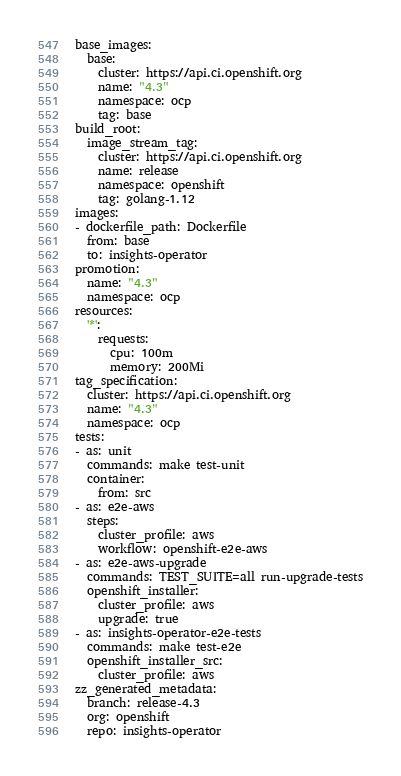Convert code to text. <code><loc_0><loc_0><loc_500><loc_500><_YAML_>base_images:
  base:
    cluster: https://api.ci.openshift.org
    name: "4.3"
    namespace: ocp
    tag: base
build_root:
  image_stream_tag:
    cluster: https://api.ci.openshift.org
    name: release
    namespace: openshift
    tag: golang-1.12
images:
- dockerfile_path: Dockerfile
  from: base
  to: insights-operator
promotion:
  name: "4.3"
  namespace: ocp
resources:
  '*':
    requests:
      cpu: 100m
      memory: 200Mi
tag_specification:
  cluster: https://api.ci.openshift.org
  name: "4.3"
  namespace: ocp
tests:
- as: unit
  commands: make test-unit
  container:
    from: src
- as: e2e-aws
  steps:
    cluster_profile: aws
    workflow: openshift-e2e-aws
- as: e2e-aws-upgrade
  commands: TEST_SUITE=all run-upgrade-tests
  openshift_installer:
    cluster_profile: aws
    upgrade: true
- as: insights-operator-e2e-tests
  commands: make test-e2e
  openshift_installer_src:
    cluster_profile: aws
zz_generated_metadata:
  branch: release-4.3
  org: openshift
  repo: insights-operator
</code> 